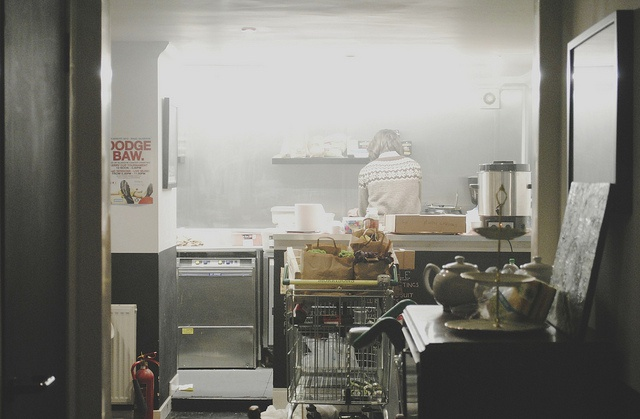Describe the objects in this image and their specific colors. I can see oven in black, gray, and darkgray tones, people in black, darkgray, and lightgray tones, bottle in black and gray tones, bottle in black, lightgray, gray, darkgray, and tan tones, and bottle in black, gray, darkgray, and darkgreen tones in this image. 